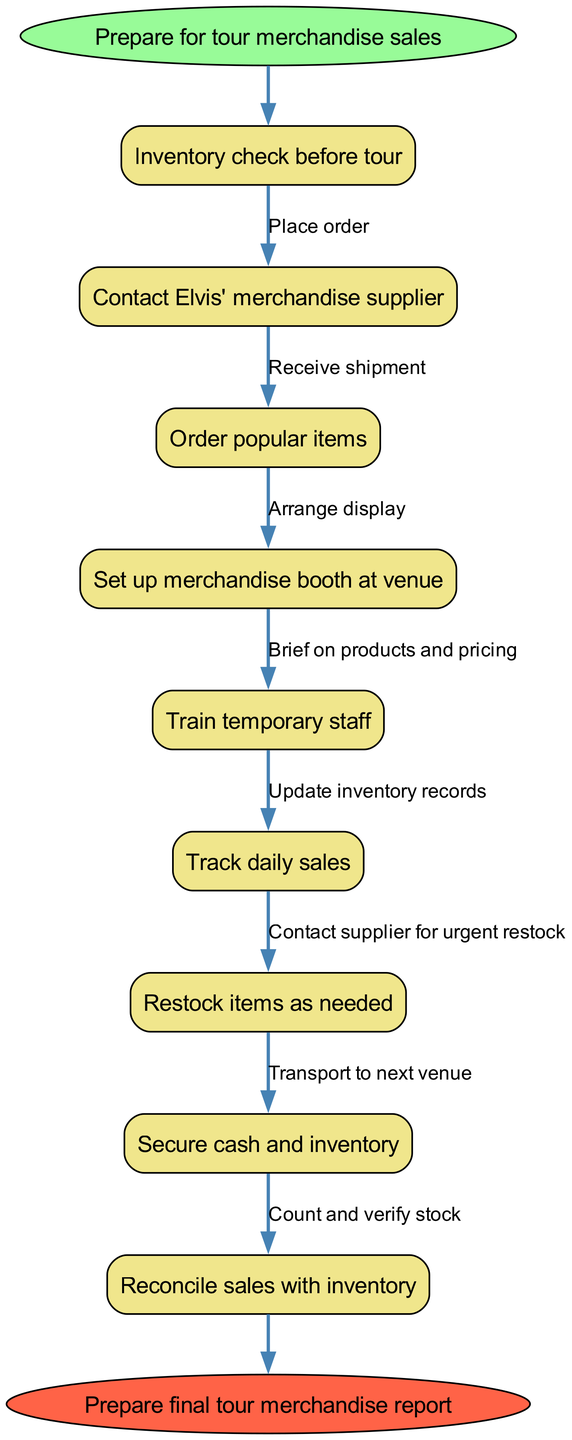What is the first step in the process? The flow chart starts with the node labeled "Prepare for tour merchandise sales," which indicates the initial action to take before proceeding with other tasks.
Answer: Prepare for tour merchandise sales How many nodes are in the diagram? Counting all the described tasks and start/end points, there are a total of 10 nodes represented in the diagram: 8 process nodes plus the start and end nodes.
Answer: 10 What does the edge labeled "Place order" connect? The edge "Place order" connects the first node "Inventory check before tour" to the second node "Contact Elvis' merchandise supplier," indicating the action that follows the inventory check.
Answer: Contact Elvis' merchandise supplier What is the last step before preparing the final report? The last process before preparing the final report is "Reconcile sales with inventory," which indicates the final task to ensure accurate representation of sales against the stock before concluding the process.
Answer: Reconcile sales with inventory Which step involves training staff? The step that involves training staff is labeled "Train temporary staff," indicating that part of the preparation includes preparing those who will be assisting with merchandise sales during the tour.
Answer: Train temporary staff What is the connection between "Restock items as needed" and "Track daily sales"? The connection between "Restock items as needed" and "Track daily sales" indicates that once daily sales are tracked, the subsequent action may involve restocking items if sales patterns require it.
Answer: Restock items as needed Which node connects to the end of the process? The node that directly connects to the end of the process, labeled "Prepare final tour merchandise report," comes after the last process "Reconcile sales with inventory," completing the flow.
Answer: Prepare final tour merchandise report How many edges are in the diagram? The diagram features 9 edges, which connect the various nodes, illustrating the sequence of actions to be taken throughout the merchandise sales and inventory management process.
Answer: 9 What action is taken after receiving the shipment? After receiving the shipment, the action taken is to "Arrange display," which is the subsequent task that organizes merchandise for sale following inventory arrival.
Answer: Arrange display 